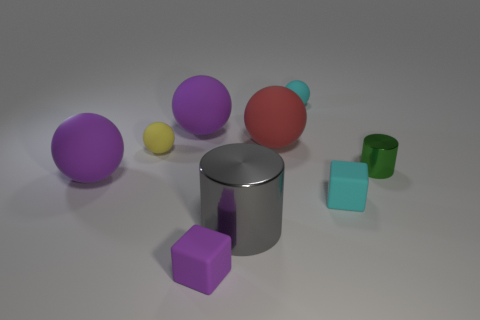Subtract all large red spheres. How many spheres are left? 4 Subtract all gray blocks. How many purple balls are left? 2 Subtract 3 balls. How many balls are left? 2 Subtract all red balls. How many balls are left? 4 Add 9 big cylinders. How many big cylinders are left? 10 Add 6 gray metal things. How many gray metal things exist? 7 Subtract 0 brown balls. How many objects are left? 9 Subtract all blocks. How many objects are left? 7 Subtract all blue cylinders. Subtract all purple spheres. How many cylinders are left? 2 Subtract all big gray cubes. Subtract all big purple spheres. How many objects are left? 7 